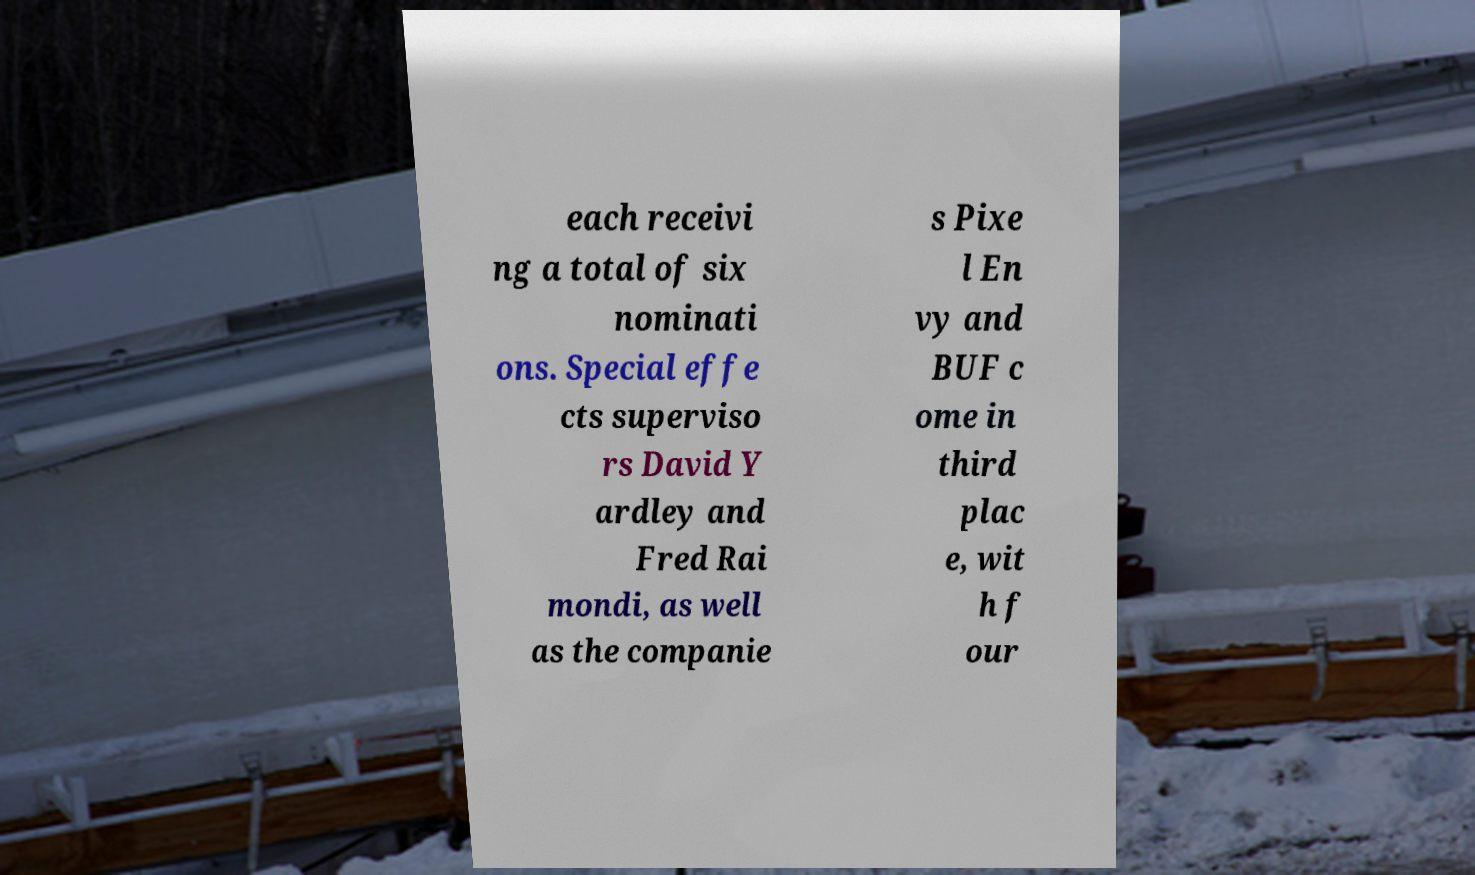Can you read and provide the text displayed in the image?This photo seems to have some interesting text. Can you extract and type it out for me? each receivi ng a total of six nominati ons. Special effe cts superviso rs David Y ardley and Fred Rai mondi, as well as the companie s Pixe l En vy and BUF c ome in third plac e, wit h f our 